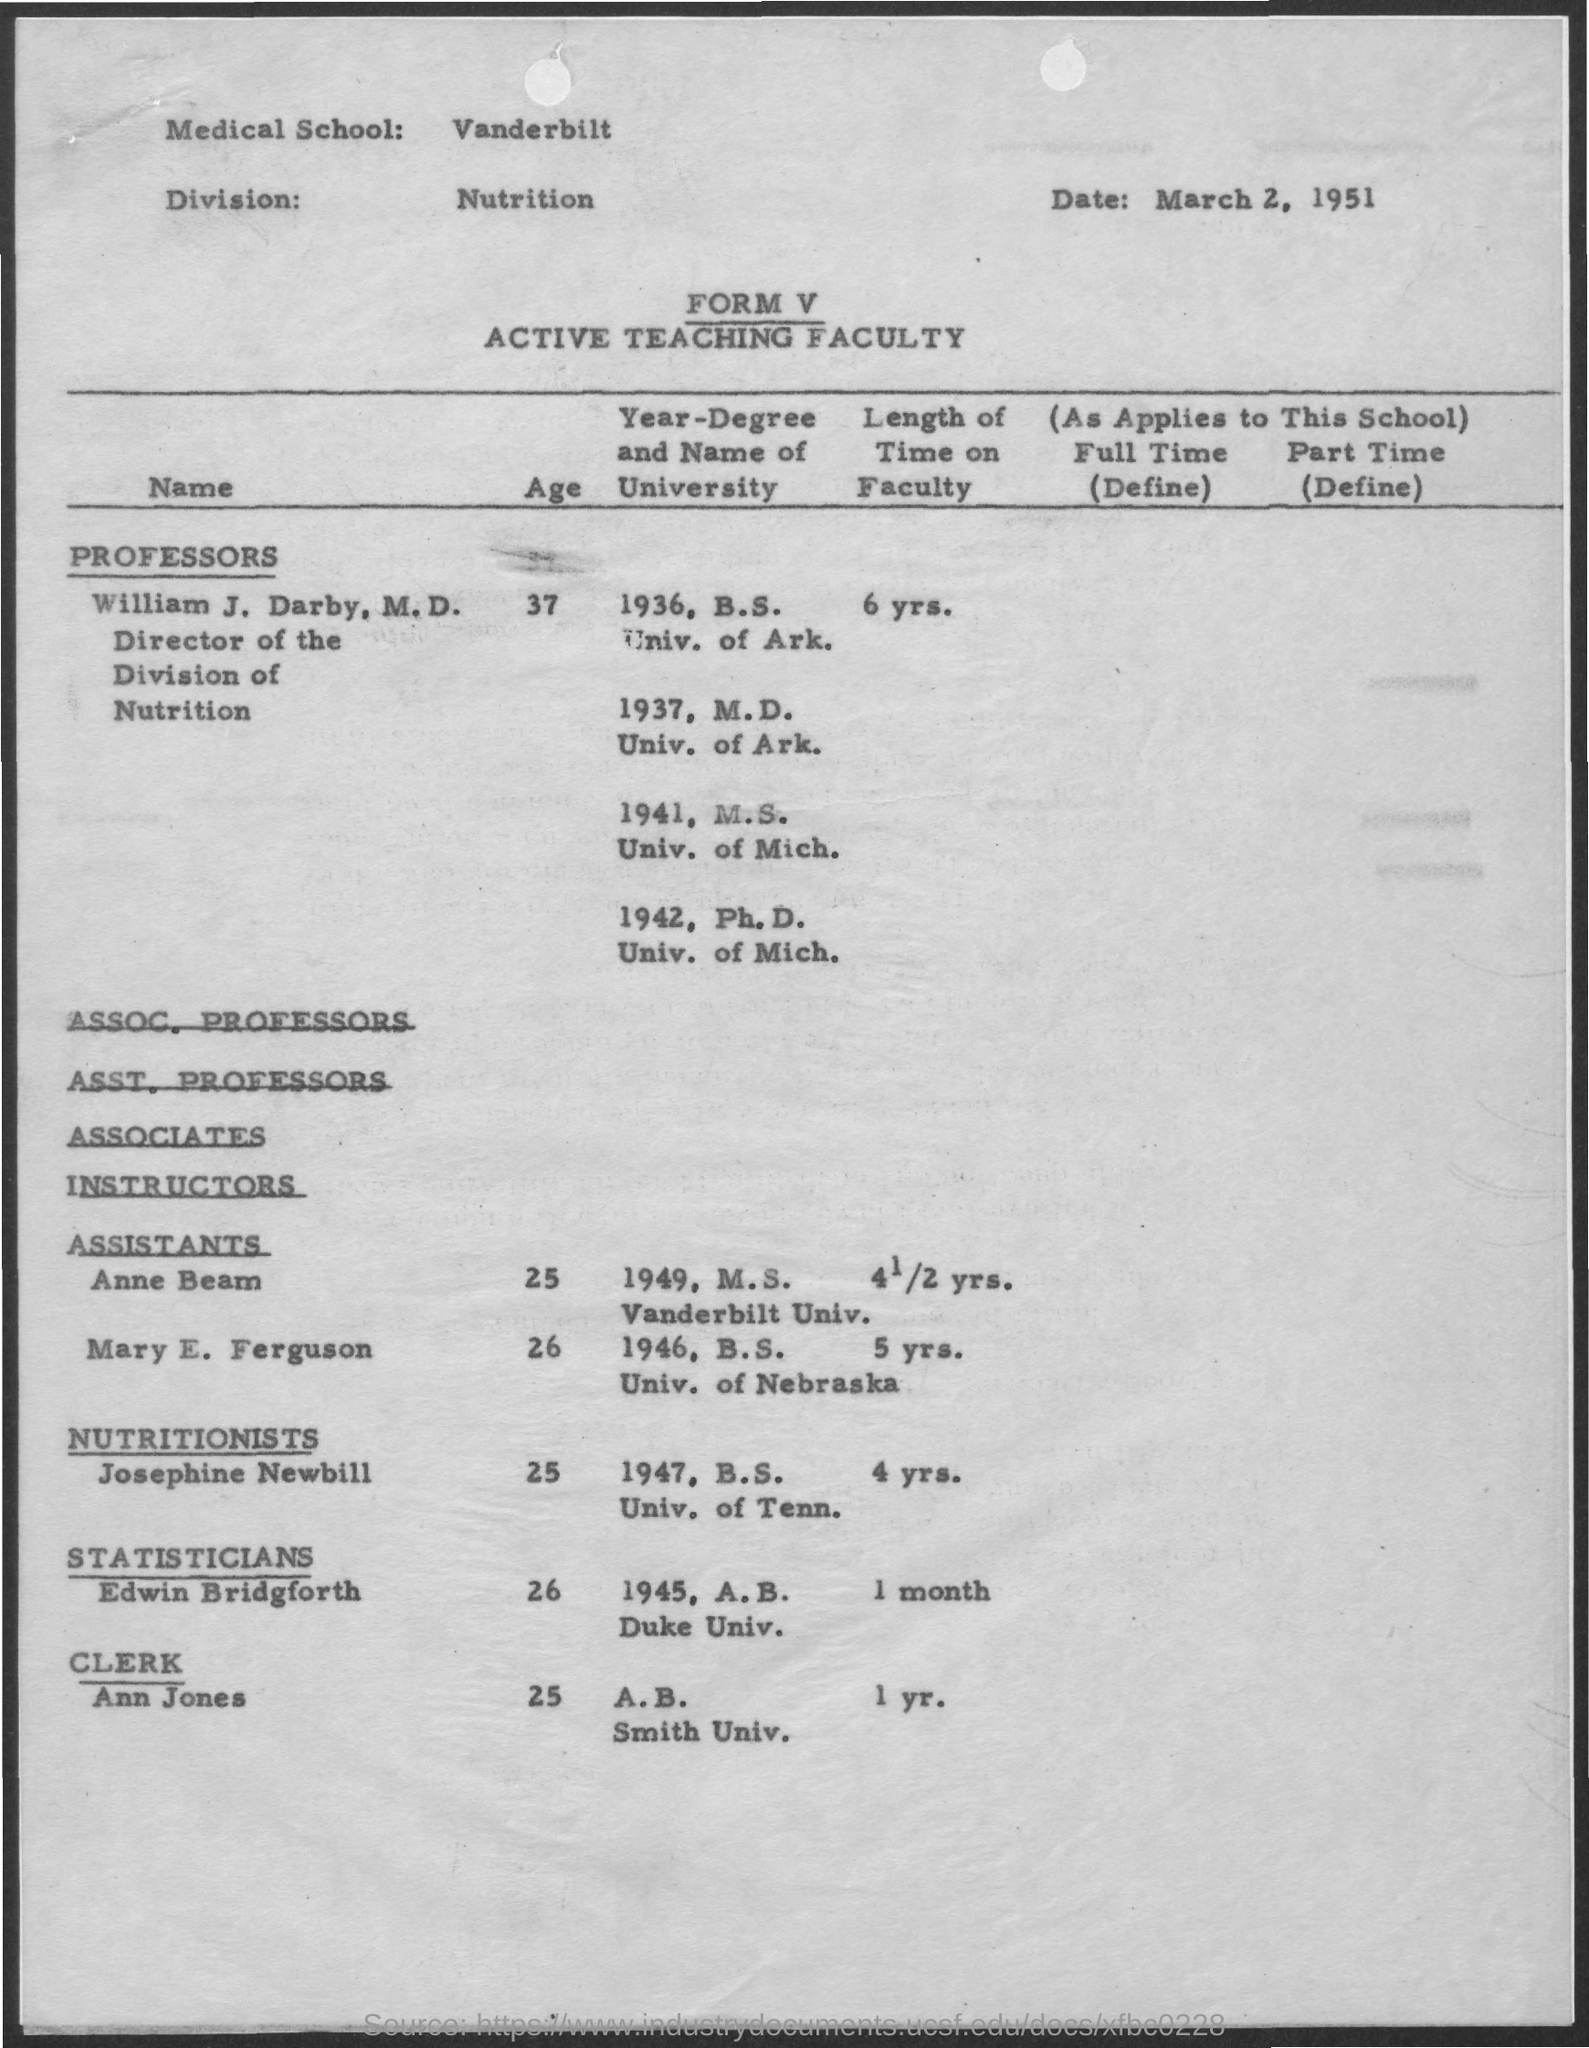What is the date mentioned ?
Make the answer very short. March 2, 1951. Who is the director the division of nutrition ?
Your answer should be compact. William j. darby. What is the age of william j darby
Your answer should be compact. 37. What is the age of ann jones
Give a very brief answer. 25. What is age of edwin bridgforth
Keep it short and to the point. 26. What is the age of josephine newbill ?
Make the answer very short. 25. What is the length of time on faculty of ann jones
Offer a terse response. 1 yr. What is the length of time on faculty of edwin bridgforth
Your response must be concise. 1 month. 